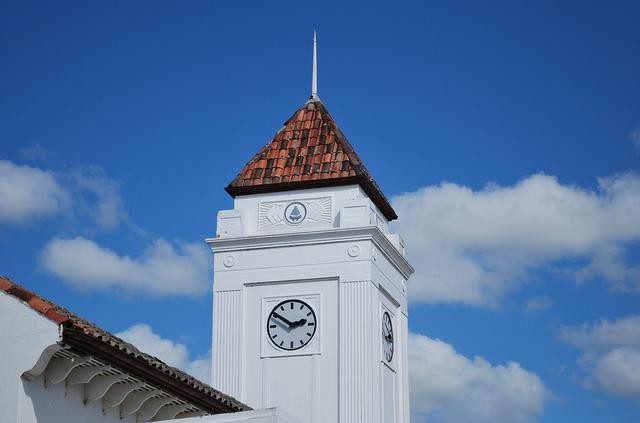Does this clock show intricate craftsmanship?
Answer briefly. Yes. How many clouds are there?
Answer briefly. 4. What is on top of the tower?
Answer briefly. Spire. What type of roof is on the building?
Write a very short answer. Shingle. What time is it?
Concise answer only. 2:50. What color is the sky?
Keep it brief. Blue. What tie does the click say?
Write a very short answer. 2:50. 